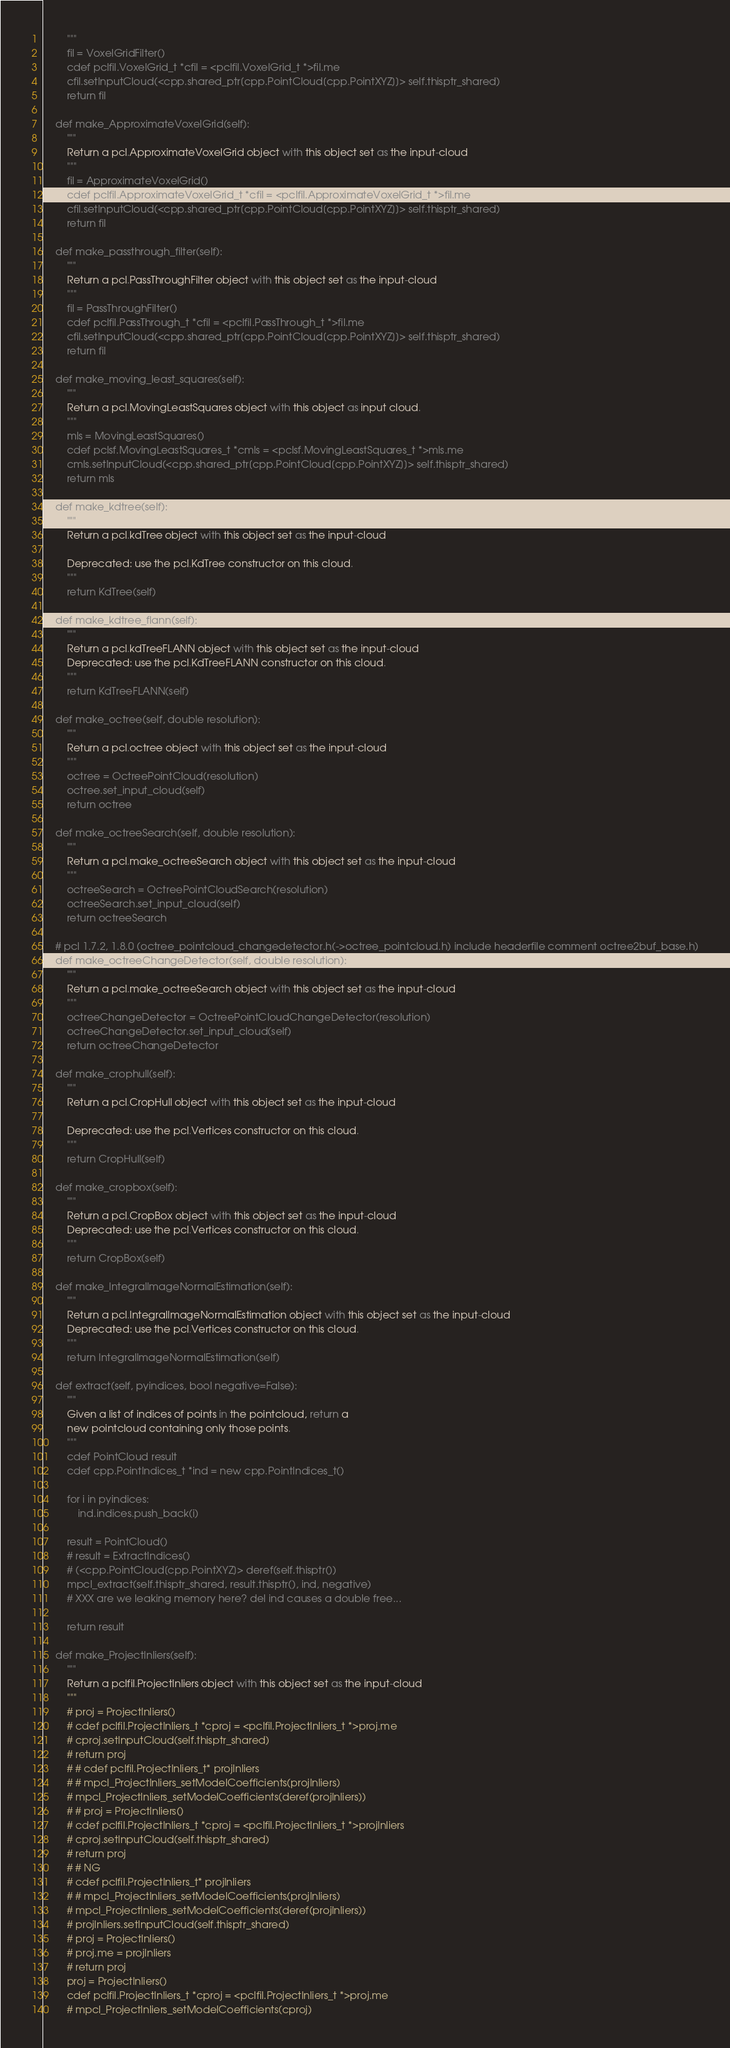<code> <loc_0><loc_0><loc_500><loc_500><_Cython_>        """
        fil = VoxelGridFilter()
        cdef pclfil.VoxelGrid_t *cfil = <pclfil.VoxelGrid_t *>fil.me
        cfil.setInputCloud(<cpp.shared_ptr[cpp.PointCloud[cpp.PointXYZ]]> self.thisptr_shared)
        return fil

    def make_ApproximateVoxelGrid(self):
        """
        Return a pcl.ApproximateVoxelGrid object with this object set as the input-cloud
        """
        fil = ApproximateVoxelGrid()
        cdef pclfil.ApproximateVoxelGrid_t *cfil = <pclfil.ApproximateVoxelGrid_t *>fil.me
        cfil.setInputCloud(<cpp.shared_ptr[cpp.PointCloud[cpp.PointXYZ]]> self.thisptr_shared)
        return fil

    def make_passthrough_filter(self):
        """
        Return a pcl.PassThroughFilter object with this object set as the input-cloud
        """
        fil = PassThroughFilter()
        cdef pclfil.PassThrough_t *cfil = <pclfil.PassThrough_t *>fil.me
        cfil.setInputCloud(<cpp.shared_ptr[cpp.PointCloud[cpp.PointXYZ]]> self.thisptr_shared)
        return fil

    def make_moving_least_squares(self):
        """
        Return a pcl.MovingLeastSquares object with this object as input cloud.
        """
        mls = MovingLeastSquares()
        cdef pclsf.MovingLeastSquares_t *cmls = <pclsf.MovingLeastSquares_t *>mls.me
        cmls.setInputCloud(<cpp.shared_ptr[cpp.PointCloud[cpp.PointXYZ]]> self.thisptr_shared)
        return mls

    def make_kdtree(self):
        """
        Return a pcl.kdTree object with this object set as the input-cloud
        
        Deprecated: use the pcl.KdTree constructor on this cloud.
        """
        return KdTree(self)

    def make_kdtree_flann(self):
        """
        Return a pcl.kdTreeFLANN object with this object set as the input-cloud
        Deprecated: use the pcl.KdTreeFLANN constructor on this cloud.
        """
        return KdTreeFLANN(self)

    def make_octree(self, double resolution):
        """
        Return a pcl.octree object with this object set as the input-cloud
        """
        octree = OctreePointCloud(resolution)
        octree.set_input_cloud(self)
        return octree

    def make_octreeSearch(self, double resolution):
        """
        Return a pcl.make_octreeSearch object with this object set as the input-cloud
        """
        octreeSearch = OctreePointCloudSearch(resolution)
        octreeSearch.set_input_cloud(self)
        return octreeSearch

    # pcl 1.7.2, 1.8.0 (octree_pointcloud_changedetector.h(->octree_pointcloud.h) include headerfile comment octree2buf_base.h)
    def make_octreeChangeDetector(self, double resolution):
        """
        Return a pcl.make_octreeSearch object with this object set as the input-cloud
        """
        octreeChangeDetector = OctreePointCloudChangeDetector(resolution)
        octreeChangeDetector.set_input_cloud(self)
        return octreeChangeDetector

    def make_crophull(self):
        """
        Return a pcl.CropHull object with this object set as the input-cloud

        Deprecated: use the pcl.Vertices constructor on this cloud.
        """
        return CropHull(self)

    def make_cropbox(self):
        """
        Return a pcl.CropBox object with this object set as the input-cloud
        Deprecated: use the pcl.Vertices constructor on this cloud.
        """
        return CropBox(self)

    def make_IntegralImageNormalEstimation(self):
        """
        Return a pcl.IntegralImageNormalEstimation object with this object set as the input-cloud
        Deprecated: use the pcl.Vertices constructor on this cloud.
        """
        return IntegralImageNormalEstimation(self)

    def extract(self, pyindices, bool negative=False):
        """
        Given a list of indices of points in the pointcloud, return a 
        new pointcloud containing only those points.
        """
        cdef PointCloud result
        cdef cpp.PointIndices_t *ind = new cpp.PointIndices_t()
        
        for i in pyindices:
            ind.indices.push_back(i)
        
        result = PointCloud()
        # result = ExtractIndices()
        # (<cpp.PointCloud[cpp.PointXYZ]> deref(self.thisptr())
        mpcl_extract(self.thisptr_shared, result.thisptr(), ind, negative)
        # XXX are we leaking memory here? del ind causes a double free...
        
        return result

    def make_ProjectInliers(self):
        """
        Return a pclfil.ProjectInliers object with this object set as the input-cloud
        """
        # proj = ProjectInliers()
        # cdef pclfil.ProjectInliers_t *cproj = <pclfil.ProjectInliers_t *>proj.me
        # cproj.setInputCloud(self.thisptr_shared)
        # return proj
        # # cdef pclfil.ProjectInliers_t* projInliers
        # # mpcl_ProjectInliers_setModelCoefficients(projInliers)
        # mpcl_ProjectInliers_setModelCoefficients(deref(projInliers))
        # # proj = ProjectInliers()
        # cdef pclfil.ProjectInliers_t *cproj = <pclfil.ProjectInliers_t *>projInliers
        # cproj.setInputCloud(self.thisptr_shared)
        # return proj
        # # NG
        # cdef pclfil.ProjectInliers_t* projInliers
        # # mpcl_ProjectInliers_setModelCoefficients(projInliers)
        # mpcl_ProjectInliers_setModelCoefficients(deref(projInliers))
        # projInliers.setInputCloud(self.thisptr_shared)
        # proj = ProjectInliers()
        # proj.me = projInliers
        # return proj
        proj = ProjectInliers()
        cdef pclfil.ProjectInliers_t *cproj = <pclfil.ProjectInliers_t *>proj.me
        # mpcl_ProjectInliers_setModelCoefficients(cproj)</code> 